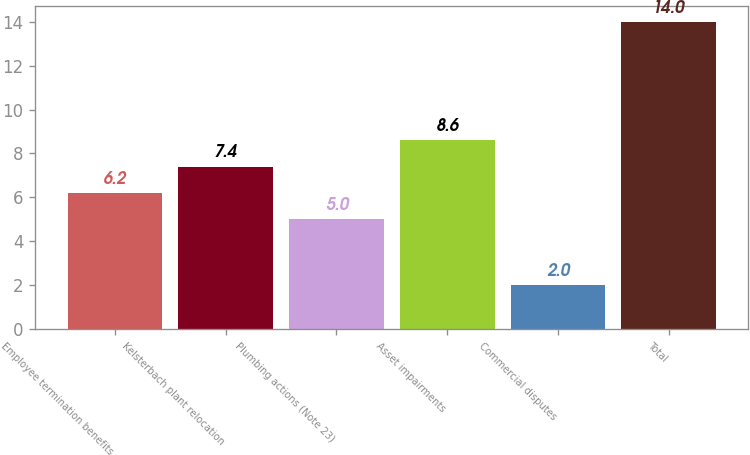Convert chart to OTSL. <chart><loc_0><loc_0><loc_500><loc_500><bar_chart><fcel>Employee termination benefits<fcel>Kelsterbach plant relocation<fcel>Plumbing actions (Note 23)<fcel>Asset impairments<fcel>Commercial disputes<fcel>Total<nl><fcel>6.2<fcel>7.4<fcel>5<fcel>8.6<fcel>2<fcel>14<nl></chart> 